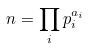Convert formula to latex. <formula><loc_0><loc_0><loc_500><loc_500>n = \prod _ { i } p _ { i } ^ { a _ { i } }</formula> 